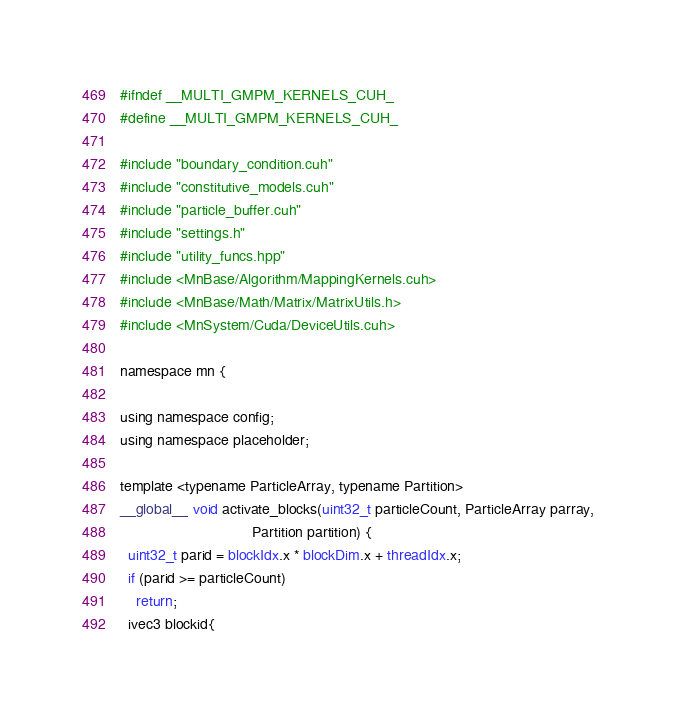<code> <loc_0><loc_0><loc_500><loc_500><_Cuda_>#ifndef __MULTI_GMPM_KERNELS_CUH_
#define __MULTI_GMPM_KERNELS_CUH_

#include "boundary_condition.cuh"
#include "constitutive_models.cuh"
#include "particle_buffer.cuh"
#include "settings.h"
#include "utility_funcs.hpp"
#include <MnBase/Algorithm/MappingKernels.cuh>
#include <MnBase/Math/Matrix/MatrixUtils.h>
#include <MnSystem/Cuda/DeviceUtils.cuh>

namespace mn {

using namespace config;
using namespace placeholder;

template <typename ParticleArray, typename Partition>
__global__ void activate_blocks(uint32_t particleCount, ParticleArray parray,
                                Partition partition) {
  uint32_t parid = blockIdx.x * blockDim.x + threadIdx.x;
  if (parid >= particleCount)
    return;
  ivec3 blockid{</code> 